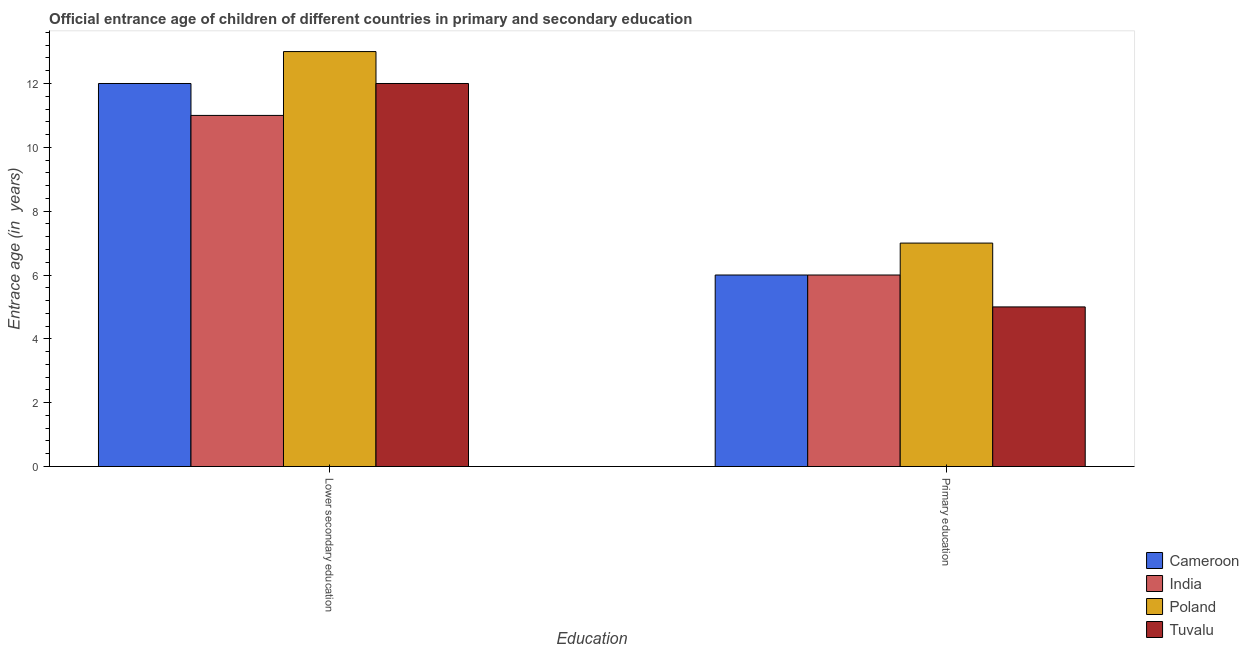How many groups of bars are there?
Your answer should be compact. 2. How many bars are there on the 1st tick from the right?
Provide a succinct answer. 4. What is the label of the 1st group of bars from the left?
Your answer should be compact. Lower secondary education. What is the entrance age of children in lower secondary education in India?
Your answer should be compact. 11. Across all countries, what is the maximum entrance age of chiildren in primary education?
Offer a terse response. 7. Across all countries, what is the minimum entrance age of children in lower secondary education?
Provide a succinct answer. 11. In which country was the entrance age of chiildren in primary education minimum?
Ensure brevity in your answer.  Tuvalu. What is the total entrance age of children in lower secondary education in the graph?
Your answer should be compact. 48. What is the difference between the entrance age of chiildren in primary education in Poland and that in Cameroon?
Offer a very short reply. 1. What is the difference between the entrance age of children in lower secondary education in Cameroon and the entrance age of chiildren in primary education in India?
Offer a very short reply. 6. What is the average entrance age of chiildren in primary education per country?
Your answer should be very brief. 6. What is the difference between the entrance age of chiildren in primary education and entrance age of children in lower secondary education in Tuvalu?
Your response must be concise. -7. What does the 3rd bar from the right in Primary education represents?
Your answer should be compact. India. Are all the bars in the graph horizontal?
Keep it short and to the point. No. Does the graph contain any zero values?
Offer a very short reply. No. What is the title of the graph?
Make the answer very short. Official entrance age of children of different countries in primary and secondary education. What is the label or title of the X-axis?
Keep it short and to the point. Education. What is the label or title of the Y-axis?
Your response must be concise. Entrace age (in  years). What is the Entrace age (in  years) in Cameroon in Lower secondary education?
Your answer should be very brief. 12. What is the Entrace age (in  years) in India in Lower secondary education?
Your answer should be very brief. 11. What is the Entrace age (in  years) in Tuvalu in Lower secondary education?
Your response must be concise. 12. What is the Entrace age (in  years) of India in Primary education?
Offer a terse response. 6. What is the Entrace age (in  years) in Tuvalu in Primary education?
Offer a terse response. 5. Across all Education, what is the maximum Entrace age (in  years) of India?
Offer a terse response. 11. Across all Education, what is the maximum Entrace age (in  years) of Tuvalu?
Your answer should be very brief. 12. Across all Education, what is the minimum Entrace age (in  years) of India?
Make the answer very short. 6. What is the difference between the Entrace age (in  years) of Cameroon in Lower secondary education and that in Primary education?
Your answer should be compact. 6. What is the difference between the Entrace age (in  years) of India in Lower secondary education and that in Primary education?
Give a very brief answer. 5. What is the difference between the Entrace age (in  years) of Cameroon in Lower secondary education and the Entrace age (in  years) of India in Primary education?
Ensure brevity in your answer.  6. What is the difference between the Entrace age (in  years) in Cameroon in Lower secondary education and the Entrace age (in  years) in Poland in Primary education?
Provide a short and direct response. 5. What is the difference between the Entrace age (in  years) of Cameroon in Lower secondary education and the Entrace age (in  years) of Tuvalu in Primary education?
Ensure brevity in your answer.  7. What is the average Entrace age (in  years) of Cameroon per Education?
Your answer should be compact. 9. What is the difference between the Entrace age (in  years) in Cameroon and Entrace age (in  years) in Poland in Lower secondary education?
Your answer should be very brief. -1. What is the difference between the Entrace age (in  years) of India and Entrace age (in  years) of Tuvalu in Primary education?
Keep it short and to the point. 1. What is the difference between the Entrace age (in  years) of Poland and Entrace age (in  years) of Tuvalu in Primary education?
Provide a succinct answer. 2. What is the ratio of the Entrace age (in  years) in India in Lower secondary education to that in Primary education?
Ensure brevity in your answer.  1.83. What is the ratio of the Entrace age (in  years) of Poland in Lower secondary education to that in Primary education?
Provide a short and direct response. 1.86. What is the ratio of the Entrace age (in  years) of Tuvalu in Lower secondary education to that in Primary education?
Your response must be concise. 2.4. What is the difference between the highest and the second highest Entrace age (in  years) of Poland?
Your response must be concise. 6. 